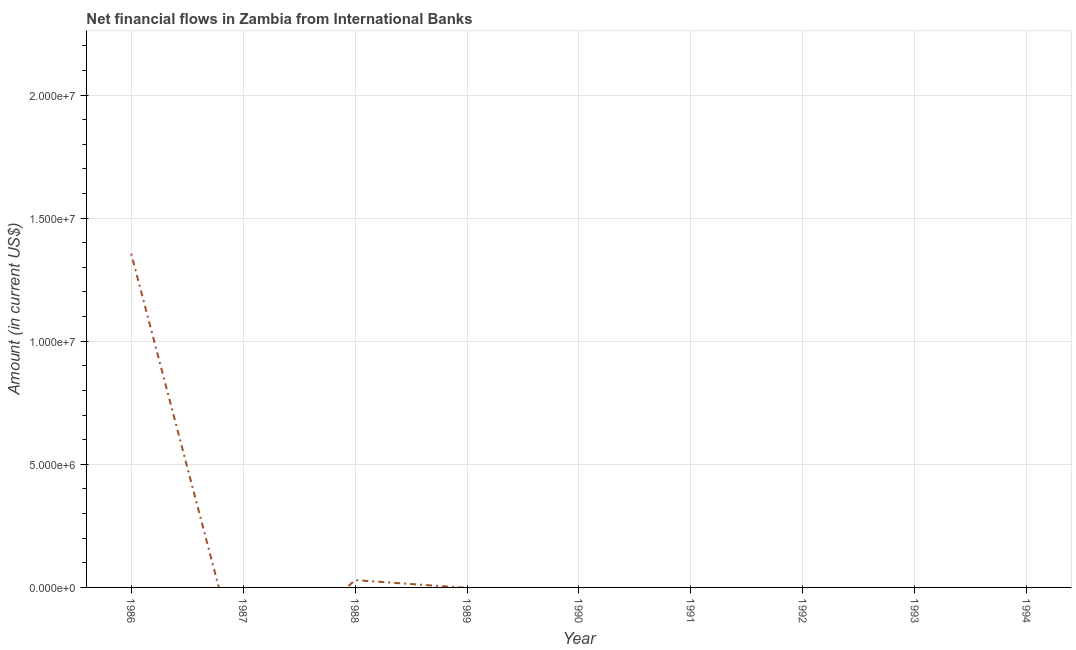What is the net financial flows from ibrd in 1988?
Your response must be concise. 2.97e+05. Across all years, what is the maximum net financial flows from ibrd?
Your answer should be very brief. 1.36e+07. What is the sum of the net financial flows from ibrd?
Your response must be concise. 1.39e+07. What is the average net financial flows from ibrd per year?
Offer a very short reply. 1.54e+06. What is the median net financial flows from ibrd?
Provide a succinct answer. 0. What is the difference between the highest and the lowest net financial flows from ibrd?
Offer a terse response. 1.36e+07. In how many years, is the net financial flows from ibrd greater than the average net financial flows from ibrd taken over all years?
Your answer should be compact. 1. Does the net financial flows from ibrd monotonically increase over the years?
Keep it short and to the point. No. How many years are there in the graph?
Offer a very short reply. 9. Are the values on the major ticks of Y-axis written in scientific E-notation?
Make the answer very short. Yes. Does the graph contain any zero values?
Offer a very short reply. Yes. What is the title of the graph?
Provide a short and direct response. Net financial flows in Zambia from International Banks. What is the label or title of the X-axis?
Keep it short and to the point. Year. What is the label or title of the Y-axis?
Provide a succinct answer. Amount (in current US$). What is the Amount (in current US$) of 1986?
Your answer should be very brief. 1.36e+07. What is the Amount (in current US$) of 1988?
Give a very brief answer. 2.97e+05. What is the Amount (in current US$) of 1989?
Ensure brevity in your answer.  0. What is the Amount (in current US$) in 1993?
Ensure brevity in your answer.  0. What is the Amount (in current US$) of 1994?
Keep it short and to the point. 0. What is the difference between the Amount (in current US$) in 1986 and 1988?
Provide a succinct answer. 1.33e+07. What is the ratio of the Amount (in current US$) in 1986 to that in 1988?
Your response must be concise. 45.64. 